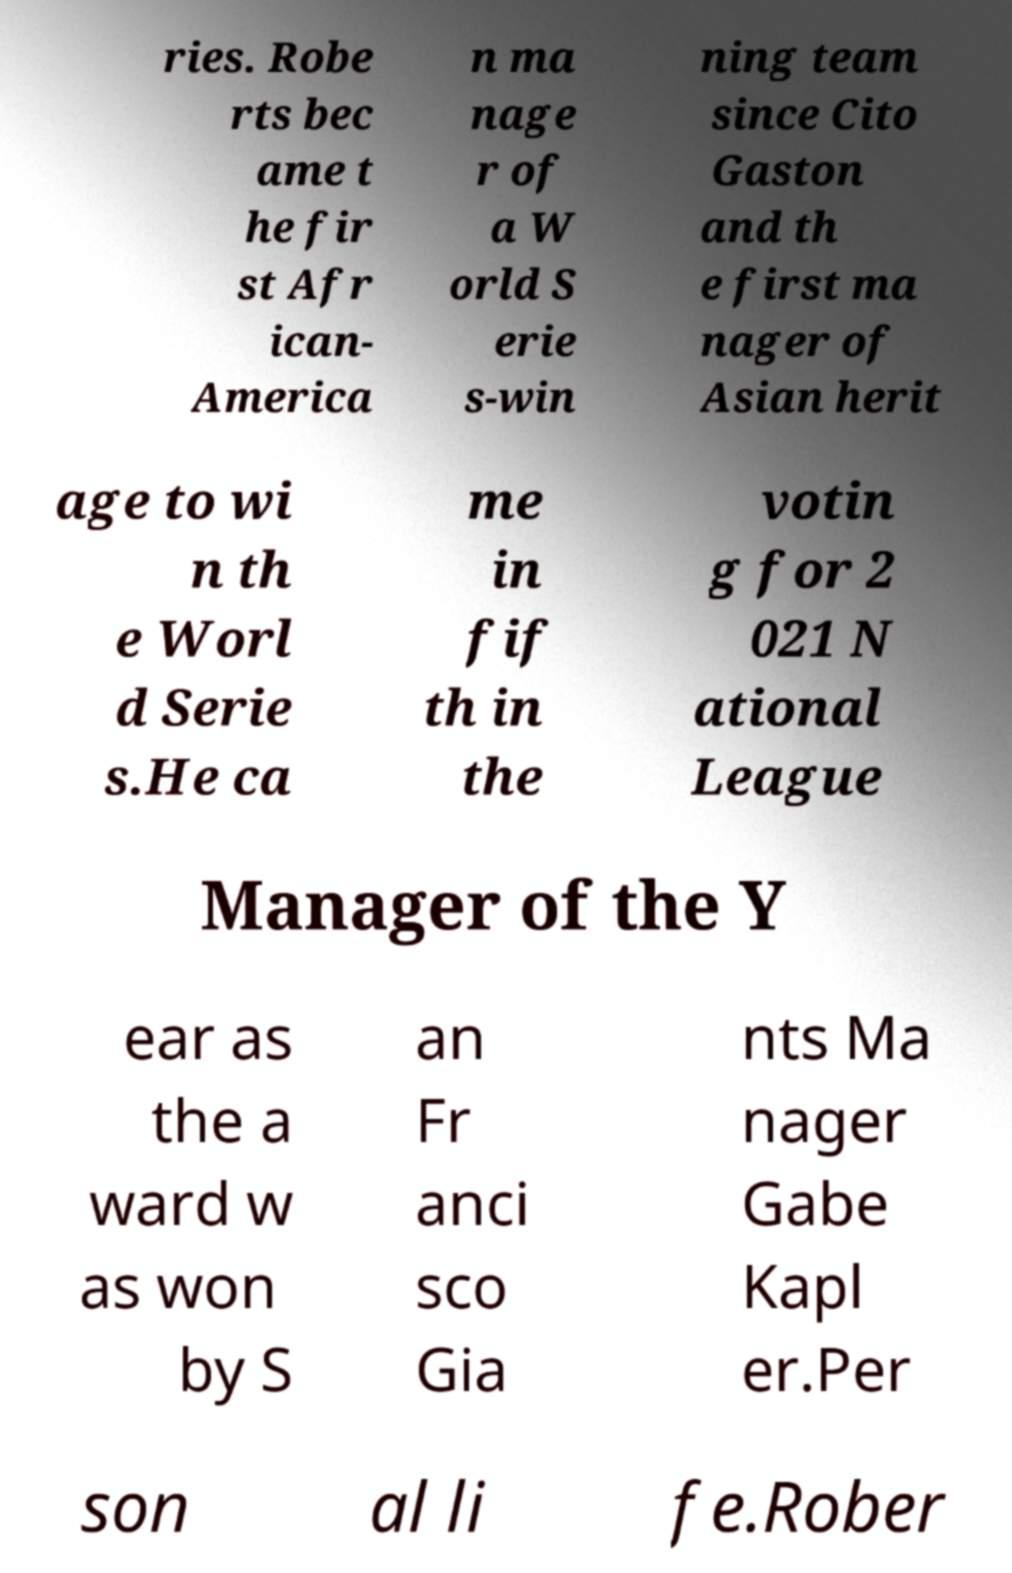Could you assist in decoding the text presented in this image and type it out clearly? ries. Robe rts bec ame t he fir st Afr ican- America n ma nage r of a W orld S erie s-win ning team since Cito Gaston and th e first ma nager of Asian herit age to wi n th e Worl d Serie s.He ca me in fif th in the votin g for 2 021 N ational League Manager of the Y ear as the a ward w as won by S an Fr anci sco Gia nts Ma nager Gabe Kapl er.Per son al li fe.Rober 